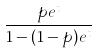<formula> <loc_0><loc_0><loc_500><loc_500>\frac { p e ^ { t } } { 1 - ( 1 - p ) e ^ { t } }</formula> 